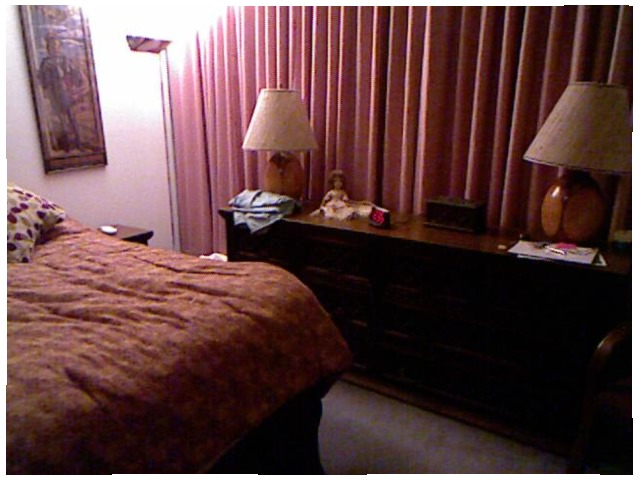<image>
Is there a lamp on the dresser? Yes. Looking at the image, I can see the lamp is positioned on top of the dresser, with the dresser providing support. 